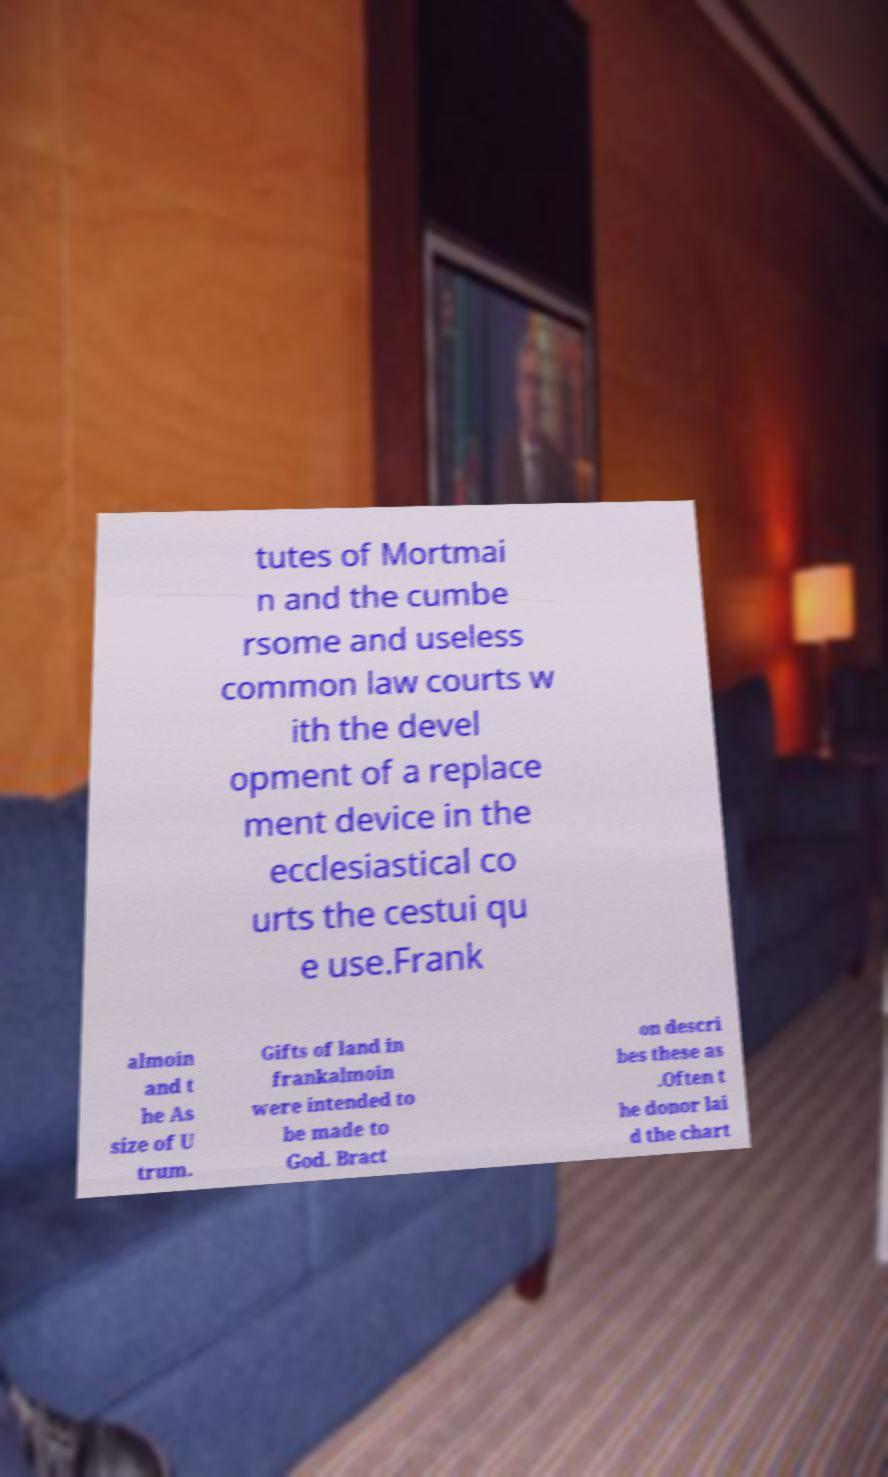For documentation purposes, I need the text within this image transcribed. Could you provide that? tutes of Mortmai n and the cumbe rsome and useless common law courts w ith the devel opment of a replace ment device in the ecclesiastical co urts the cestui qu e use.Frank almoin and t he As size of U trum. Gifts of land in frankalmoin were intended to be made to God. Bract on descri bes these as .Often t he donor lai d the chart 